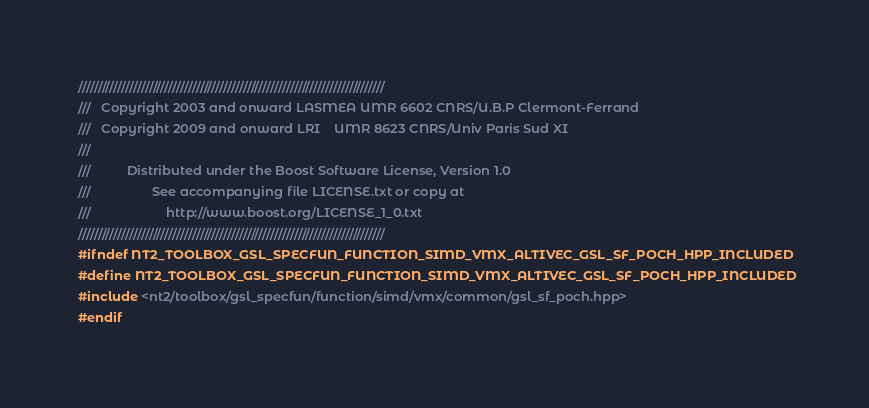<code> <loc_0><loc_0><loc_500><loc_500><_C++_>//////////////////////////////////////////////////////////////////////////////
///   Copyright 2003 and onward LASMEA UMR 6602 CNRS/U.B.P Clermont-Ferrand
///   Copyright 2009 and onward LRI    UMR 8623 CNRS/Univ Paris Sud XI
///
///          Distributed under the Boost Software License, Version 1.0
///                 See accompanying file LICENSE.txt or copy at
///                     http://www.boost.org/LICENSE_1_0.txt
//////////////////////////////////////////////////////////////////////////////
#ifndef NT2_TOOLBOX_GSL_SPECFUN_FUNCTION_SIMD_VMX_ALTIVEC_GSL_SF_POCH_HPP_INCLUDED
#define NT2_TOOLBOX_GSL_SPECFUN_FUNCTION_SIMD_VMX_ALTIVEC_GSL_SF_POCH_HPP_INCLUDED
#include <nt2/toolbox/gsl_specfun/function/simd/vmx/common/gsl_sf_poch.hpp>
#endif
</code> 